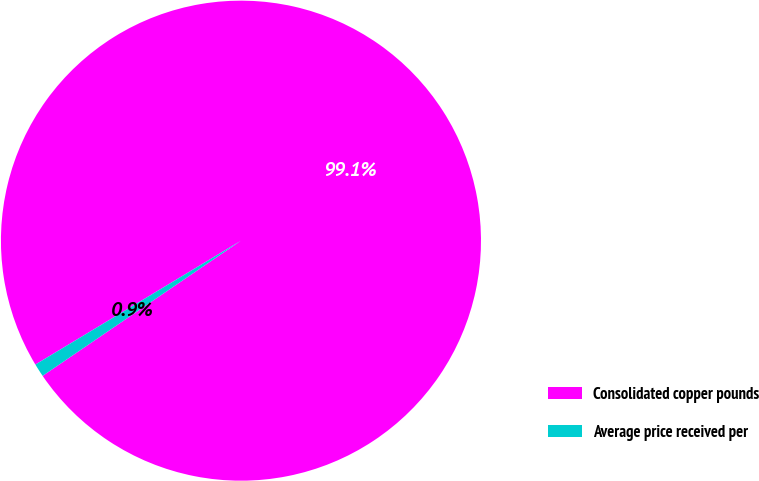Convert chart to OTSL. <chart><loc_0><loc_0><loc_500><loc_500><pie_chart><fcel>Consolidated copper pounds<fcel>Average price received per<nl><fcel>99.11%<fcel>0.89%<nl></chart> 